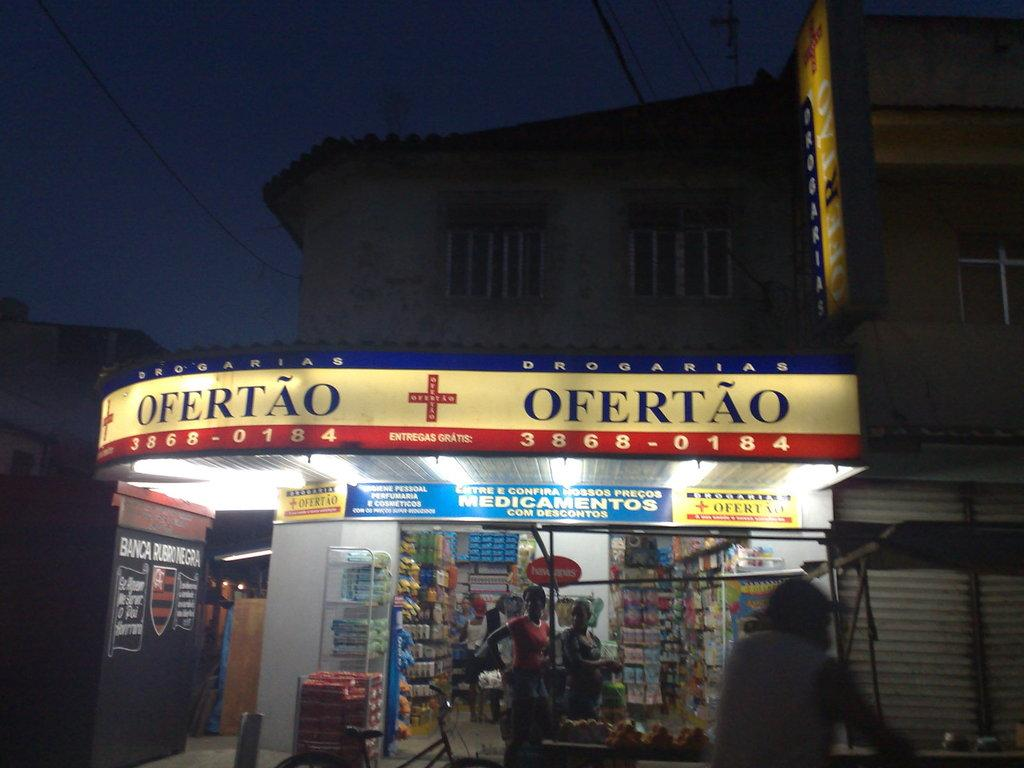<image>
Describe the image concisely. a store front with a top banner of lights that says 'ofertao' 